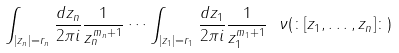<formula> <loc_0><loc_0><loc_500><loc_500>\int _ { | z _ { n } | = r _ { n } } \frac { d z _ { n } } { 2 \pi i } \frac { 1 } { z _ { n } ^ { m _ { n } + 1 } } \cdots \int _ { | z _ { 1 } | = r _ { 1 } } \frac { d z _ { 1 } } { 2 \pi i } \frac { 1 } { z _ { 1 } ^ { m _ { 1 } + 1 } } \ \nu ( \colon [ z _ { 1 } , \dots , z _ { n } ] \colon )</formula> 